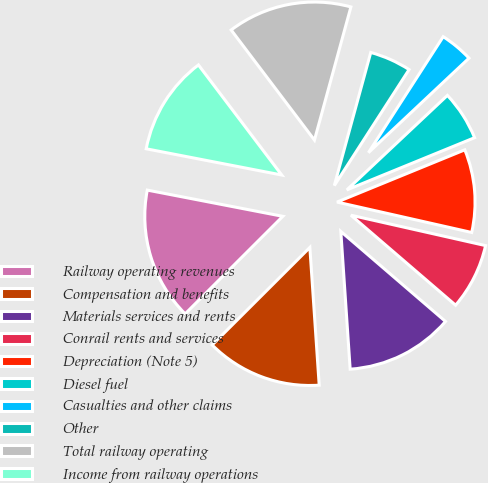Convert chart to OTSL. <chart><loc_0><loc_0><loc_500><loc_500><pie_chart><fcel>Railway operating revenues<fcel>Compensation and benefits<fcel>Materials services and rents<fcel>Conrail rents and services<fcel>Depreciation (Note 5)<fcel>Diesel fuel<fcel>Casualties and other claims<fcel>Other<fcel>Total railway operating<fcel>Income from railway operations<nl><fcel>15.53%<fcel>13.59%<fcel>12.62%<fcel>7.77%<fcel>9.71%<fcel>5.83%<fcel>3.88%<fcel>4.86%<fcel>14.56%<fcel>11.65%<nl></chart> 